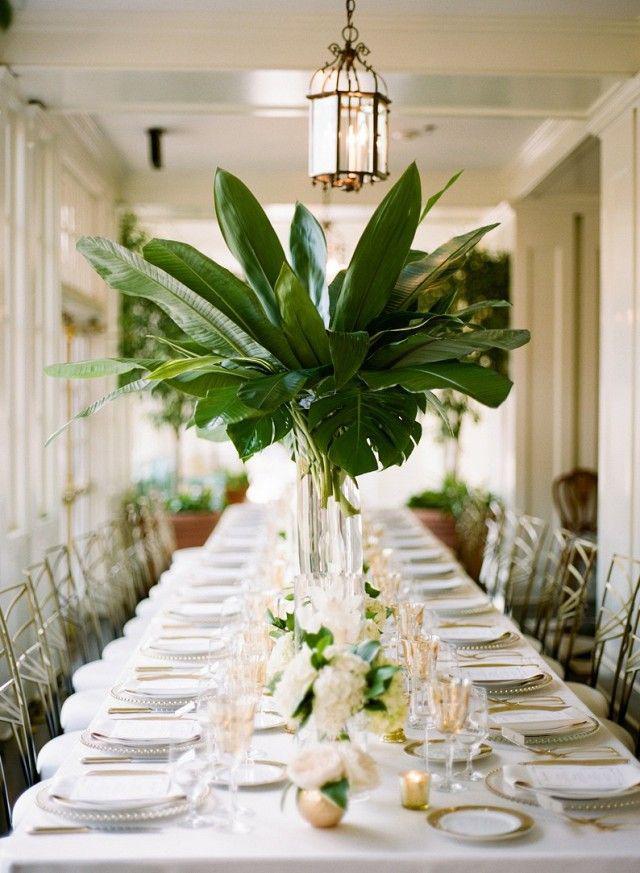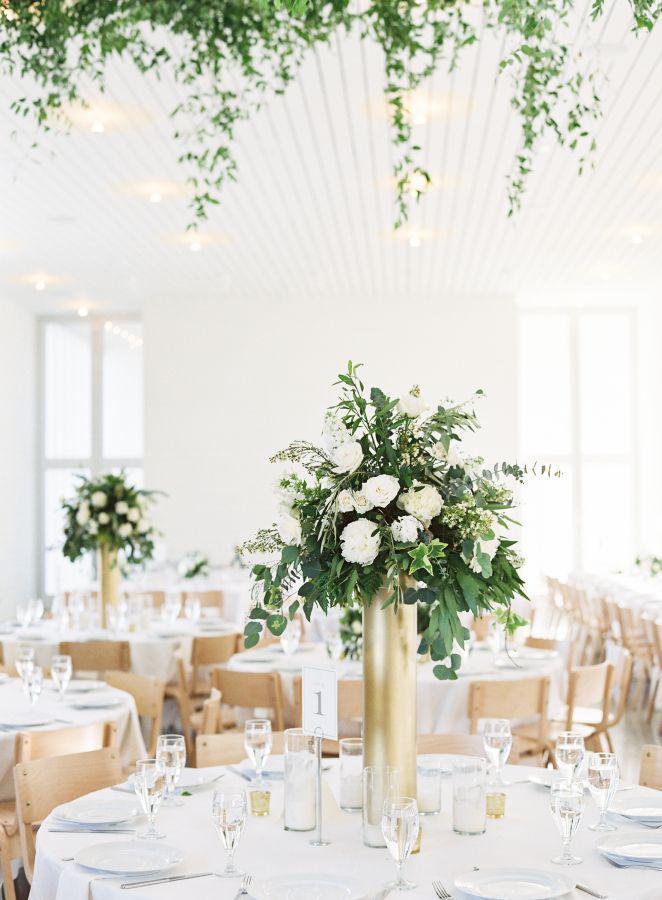The first image is the image on the left, the second image is the image on the right. Examine the images to the left and right. Is the description "A single numbered label is on top of a decorated table." accurate? Answer yes or no. No. The first image is the image on the left, the second image is the image on the right. Assess this claim about the two images: "A plant with no flowers in a tall vase is used as a centerpiece on the table.". Correct or not? Answer yes or no. Yes. 